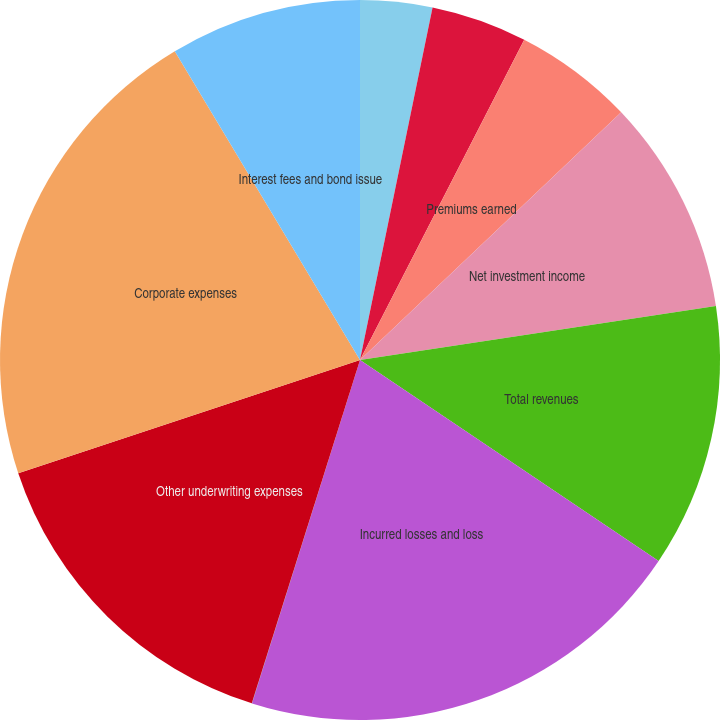Convert chart to OTSL. <chart><loc_0><loc_0><loc_500><loc_500><pie_chart><fcel>Gross written premiums<fcel>Net written premiums<fcel>Premiums earned<fcel>Net investment income<fcel>Total revenues<fcel>Incurred losses and loss<fcel>Commission brokerage taxes and<fcel>Other underwriting expenses<fcel>Corporate expenses<fcel>Interest fees and bond issue<nl><fcel>3.23%<fcel>4.31%<fcel>5.38%<fcel>9.68%<fcel>11.83%<fcel>20.42%<fcel>0.01%<fcel>15.05%<fcel>21.49%<fcel>8.6%<nl></chart> 